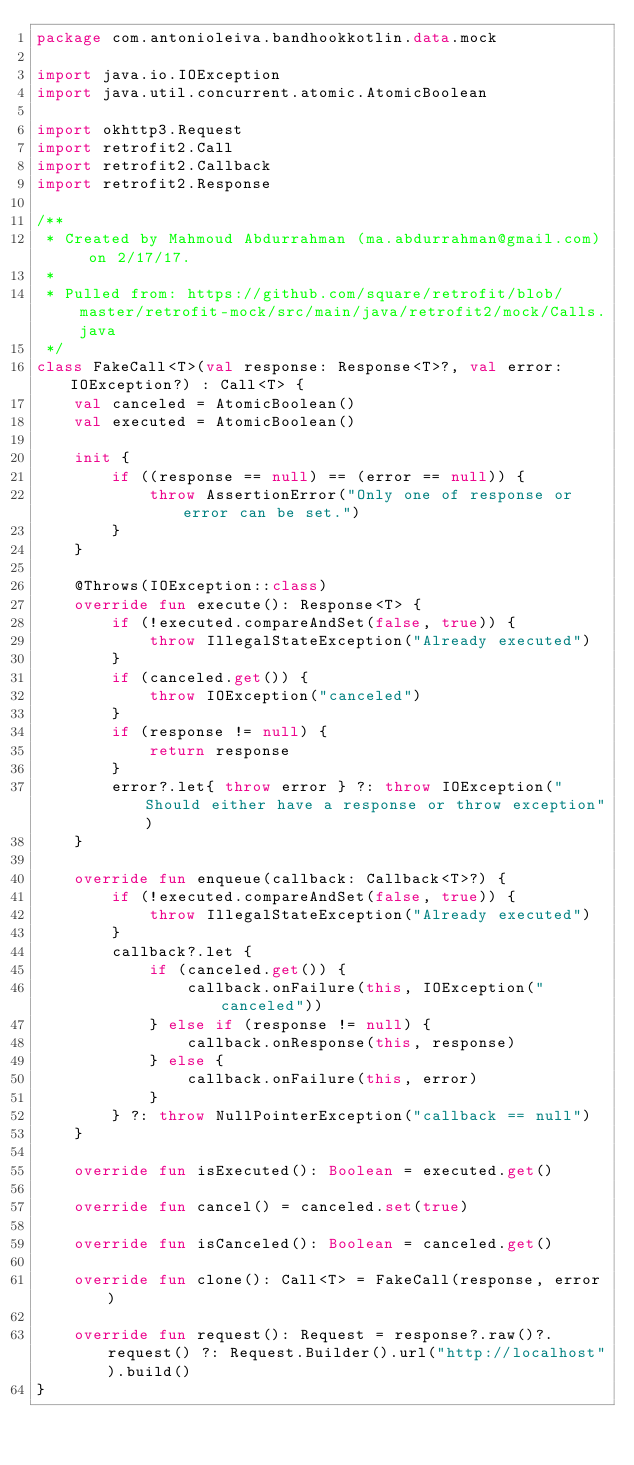<code> <loc_0><loc_0><loc_500><loc_500><_Kotlin_>package com.antonioleiva.bandhookkotlin.data.mock

import java.io.IOException
import java.util.concurrent.atomic.AtomicBoolean

import okhttp3.Request
import retrofit2.Call
import retrofit2.Callback
import retrofit2.Response

/**
 * Created by Mahmoud Abdurrahman (ma.abdurrahman@gmail.com) on 2/17/17.
 *
 * Pulled from: https://github.com/square/retrofit/blob/master/retrofit-mock/src/main/java/retrofit2/mock/Calls.java
 */
class FakeCall<T>(val response: Response<T>?, val error: IOException?) : Call<T> {
    val canceled = AtomicBoolean()
    val executed = AtomicBoolean()

    init {
        if ((response == null) == (error == null)) {
            throw AssertionError("Only one of response or error can be set.")
        }
    }

    @Throws(IOException::class)
    override fun execute(): Response<T> {
        if (!executed.compareAndSet(false, true)) {
            throw IllegalStateException("Already executed")
        }
        if (canceled.get()) {
            throw IOException("canceled")
        }
        if (response != null) {
            return response
        }
        error?.let{ throw error } ?: throw IOException("Should either have a response or throw exception")
    }

    override fun enqueue(callback: Callback<T>?) {
        if (!executed.compareAndSet(false, true)) {
            throw IllegalStateException("Already executed")
        }
        callback?.let {
            if (canceled.get()) {
                callback.onFailure(this, IOException("canceled"))
            } else if (response != null) {
                callback.onResponse(this, response)
            } else {
                callback.onFailure(this, error)
            }
        } ?: throw NullPointerException("callback == null")
    }

    override fun isExecuted(): Boolean = executed.get()

    override fun cancel() = canceled.set(true)

    override fun isCanceled(): Boolean = canceled.get()

    override fun clone(): Call<T> = FakeCall(response, error)

    override fun request(): Request = response?.raw()?.request() ?: Request.Builder().url("http://localhost").build()
}
</code> 